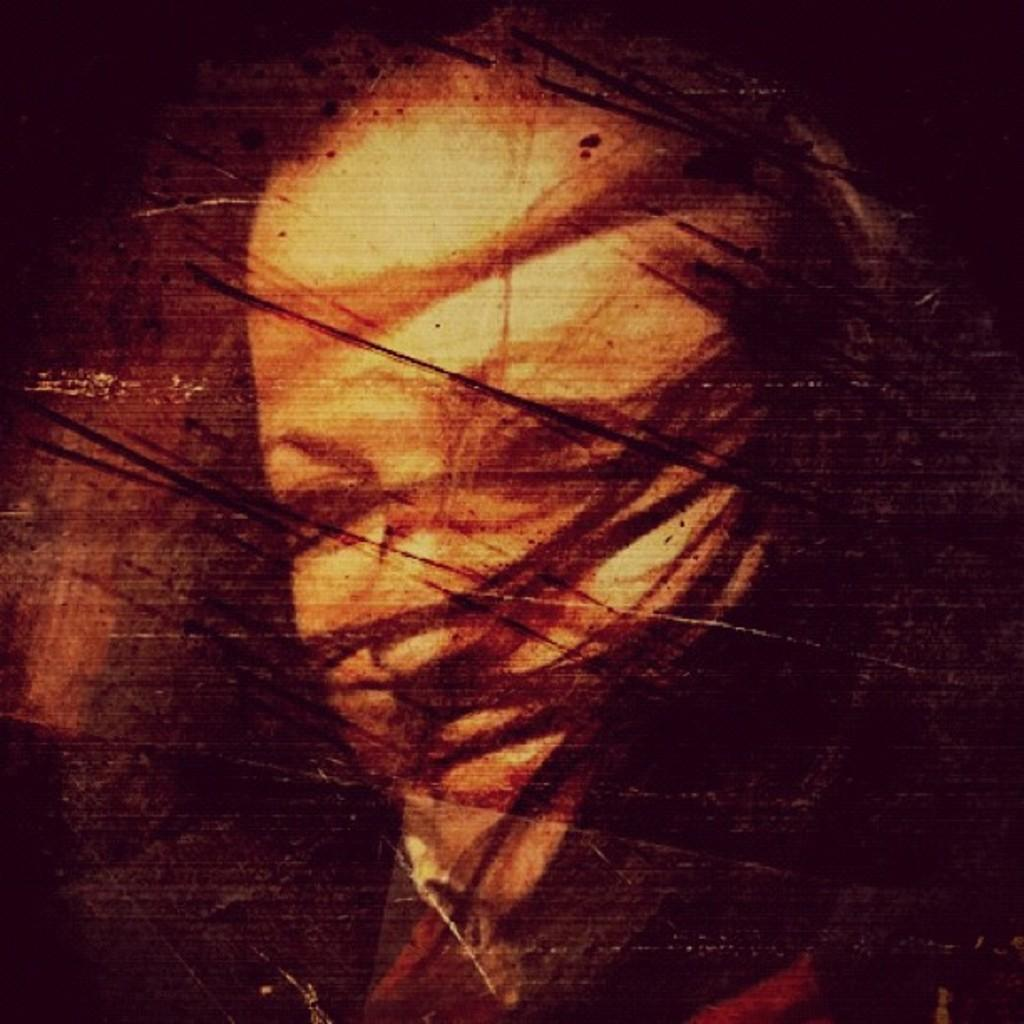What is depicted on the wall in the image? There is a painting of a person's face on the wall in the image. How deep is the ocean in the image? There is no ocean present in the image; it features a painting of a person's face on the wall. What type of power is being generated in the image? There is no power generation depicted in the image; it features a painting of a person's face on the wall. 